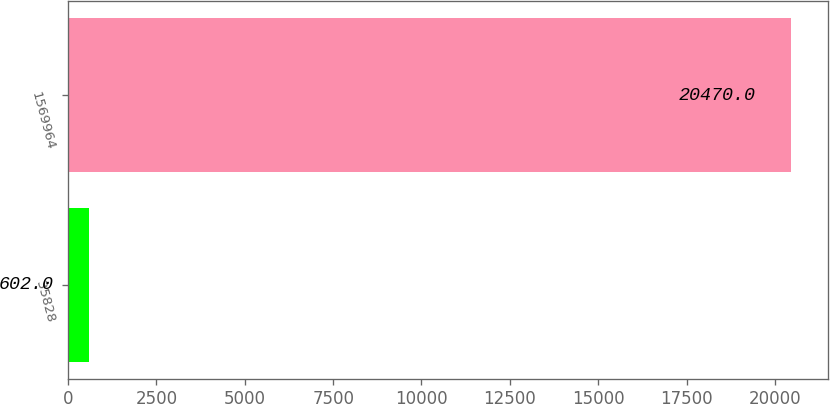Convert chart to OTSL. <chart><loc_0><loc_0><loc_500><loc_500><bar_chart><fcel>35828<fcel>1569964<nl><fcel>602<fcel>20470<nl></chart> 